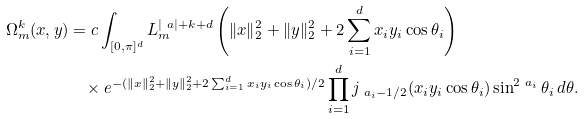<formula> <loc_0><loc_0><loc_500><loc_500>\Omega _ { m } ^ { k } ( x , y ) & = c \int _ { [ 0 , \pi ] ^ { d } } L _ { m } ^ { | \ a | + k + d } \left ( \| x \| _ { 2 } ^ { 2 } + \| y \| _ { 2 } ^ { 2 } + 2 \sum _ { i = 1 } ^ { d } x _ { i } y _ { i } \cos \theta _ { i } \right ) \\ & \quad \times e ^ { - ( \| x \| _ { 2 } ^ { 2 } + \| y \| _ { 2 } ^ { 2 } + 2 \sum _ { i = 1 } ^ { d } x _ { i } y _ { i } \cos \theta _ { i } ) / 2 } \prod _ { i = 1 } ^ { d } j _ { \ a _ { i } - 1 / 2 } ( x _ { i } y _ { i } \cos \theta _ { i } ) \sin ^ { 2 \ a _ { i } } \theta _ { i } \, d \theta .</formula> 